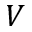Convert formula to latex. <formula><loc_0><loc_0><loc_500><loc_500>V</formula> 